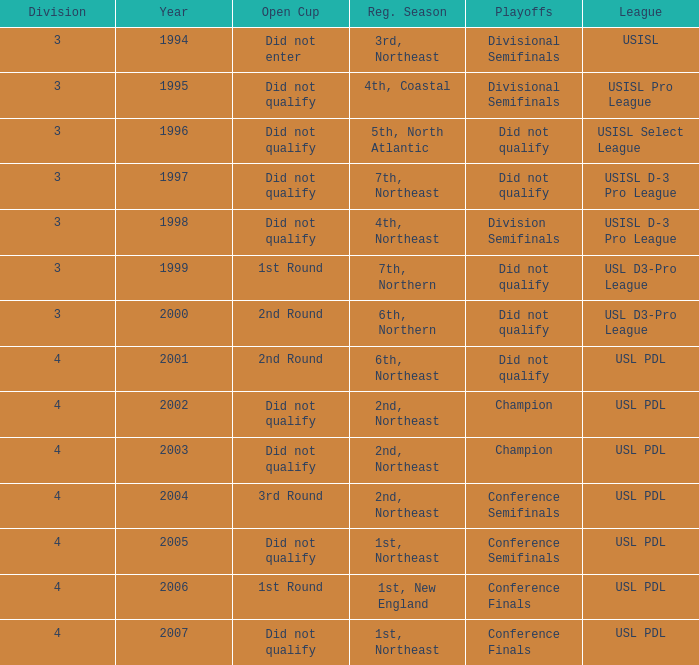Name the total number of years for usisl pro league 1.0. 